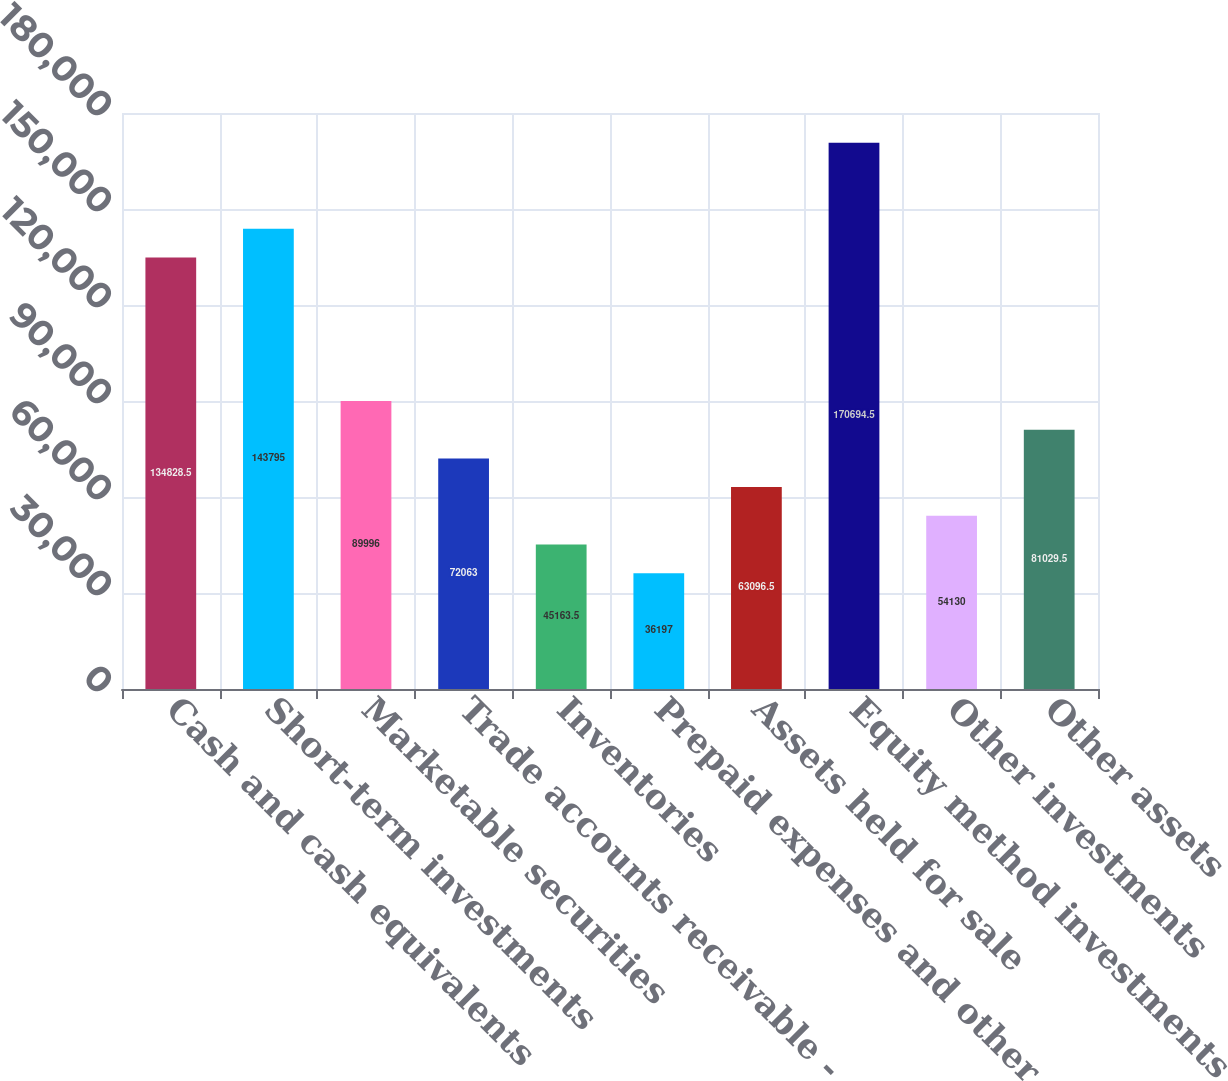Convert chart. <chart><loc_0><loc_0><loc_500><loc_500><bar_chart><fcel>Cash and cash equivalents<fcel>Short-term investments<fcel>Marketable securities<fcel>Trade accounts receivable -<fcel>Inventories<fcel>Prepaid expenses and other<fcel>Assets held for sale<fcel>Equity method investments<fcel>Other investments<fcel>Other assets<nl><fcel>134828<fcel>143795<fcel>89996<fcel>72063<fcel>45163.5<fcel>36197<fcel>63096.5<fcel>170694<fcel>54130<fcel>81029.5<nl></chart> 